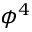<formula> <loc_0><loc_0><loc_500><loc_500>\phi ^ { 4 }</formula> 